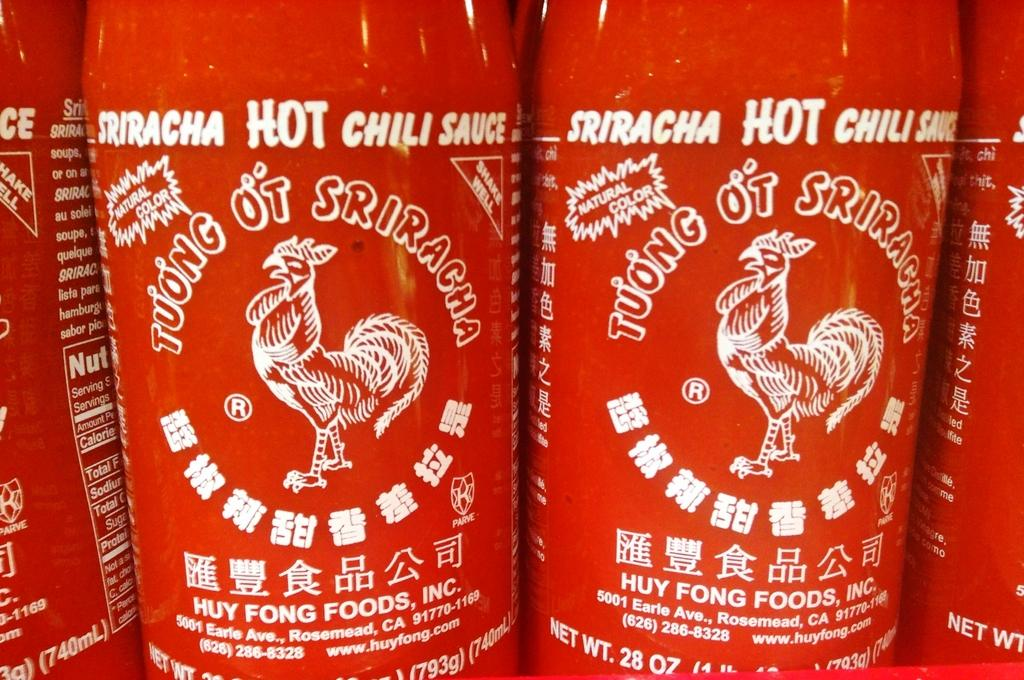<image>
Describe the image concisely. the word hot that is on a red bottle 